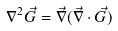<formula> <loc_0><loc_0><loc_500><loc_500>\nabla ^ { 2 } \vec { G } = \vec { \nabla } ( \vec { \nabla } \cdot \vec { G } )</formula> 